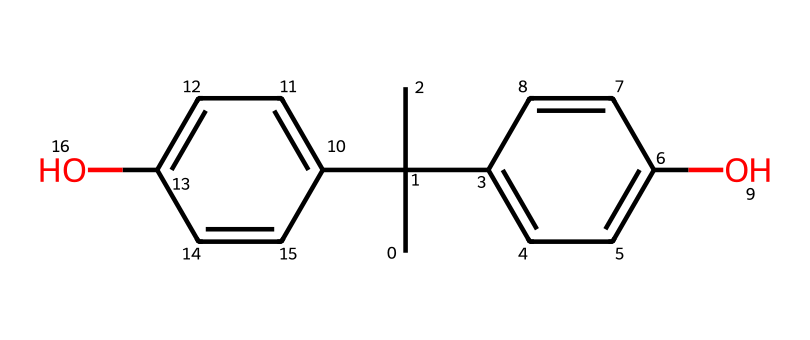What is the common name of this compound? The SMILES representation corresponds to a structure commonly known as Bisphenol A, which is a well-known industrial chemical.
Answer: Bisphenol A How many carbon atoms are in this molecule? By analyzing the SMILES, we can count the number of carbon atoms represented. Each 'C' in the formula represents a carbon atom, and when counted, there are 15 carbon atoms in total.
Answer: 15 How many hydroxyl (-OH) groups are present in this structure? The hydroxyl groups are represented by the 'O' in the SMILES followed by a 'H'. By locating the positions of 'O' in the structure, we find there are two hydroxyl groups.
Answer: 2 Does this compound have any double bonds? Examining the SMILES reveals the presence of double bonds indicated by the '=' symbol, which can be found between the carbon atoms. These double bonds make the compound unsaturated.
Answer: Yes What functional groups are present in Bisphenol A? By analyzing the structure, we identify the hydroxyl groups and the phenolic components, which indicate the presence of alcohol functional groups and aromatic rings.
Answer: Hydroxyl groups and aromatic rings What is the molecular weight of Bisphenol A? To find the molecular weight, we sum the atomic weights of all atoms present in the structure by using standard atomic weights for carbon, hydrogen, and oxygen. The total comes out to be approximately 228.29 g/mol.
Answer: 228.29 g/mol 